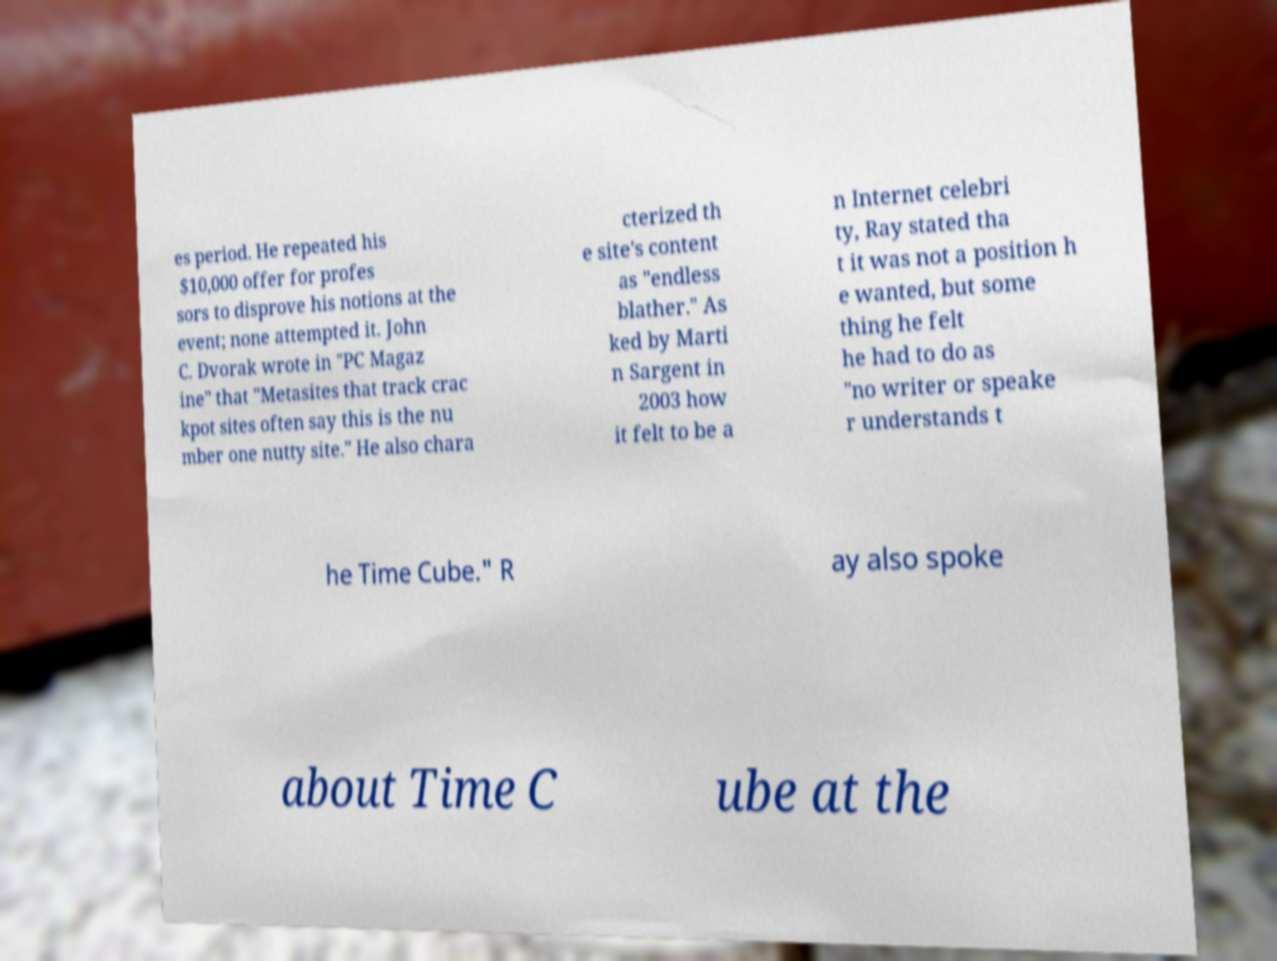Please identify and transcribe the text found in this image. es period. He repeated his $10,000 offer for profes sors to disprove his notions at the event; none attempted it. John C. Dvorak wrote in "PC Magaz ine" that "Metasites that track crac kpot sites often say this is the nu mber one nutty site." He also chara cterized th e site's content as "endless blather." As ked by Marti n Sargent in 2003 how it felt to be a n Internet celebri ty, Ray stated tha t it was not a position h e wanted, but some thing he felt he had to do as "no writer or speake r understands t he Time Cube." R ay also spoke about Time C ube at the 